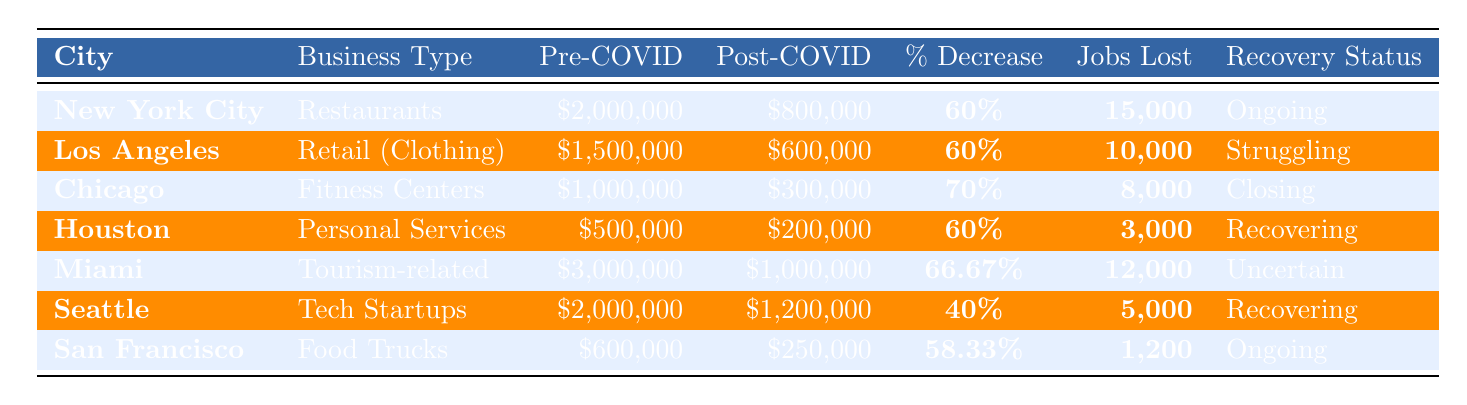What city experienced the highest percentage decrease in revenue? Looking at the percentages, Chicago shows a decrease of 70%, which is higher than any other city listed, thus it has the highest percentage decrease in revenue.
Answer: Chicago How many jobs were lost in Houston? The table clearly lists that Houston lost 3,000 jobs, which is the specific value provided for that city.
Answer: 3000 What is the average revenue decrease percentage for all the businesses? To find the average, we sum the percentages: 60% + 60% + 70% + 60% + 66.67% + 40% + 58.33% =  411% and divide by 7 (the number of businesses), resulting in an average of approximately 58.71%.
Answer: 58.71% Is the recovery status for Miami "Ongoing"? The table states that Miami's recovery status is "Uncertain," so the answer is no.
Answer: No Which city had the highest pre-COVID revenue? Upon comparison, Miami had the highest pre-COVID revenue at $3,000,000, higher than any other city's pre-COVID revenue listed.
Answer: Miami How many businesses are currently recovering of the seven listed? The cities identified with a recovery status of "Recovering" are Houston and Seattle, which means 2 out of the 7 businesses are currently recovering.
Answer: 2 What is the total number of jobs lost across all cities mentioned? By adding all the jobs lost: 15,000 (NYC) + 10,000 (LA) + 8,000 (Chicago) + 3,000 (Houston) + 12,000 (Miami) + 5,000 (Seattle) + 1,200 (San Francisco) = 54,200 total jobs lost across all cities.
Answer: 54200 Which city has the lowest post-COVID revenue? Comparing the post-COVID revenues, Chicago has the lowest at $300,000, which is less than any other city's post-COVID revenue.
Answer: Chicago 